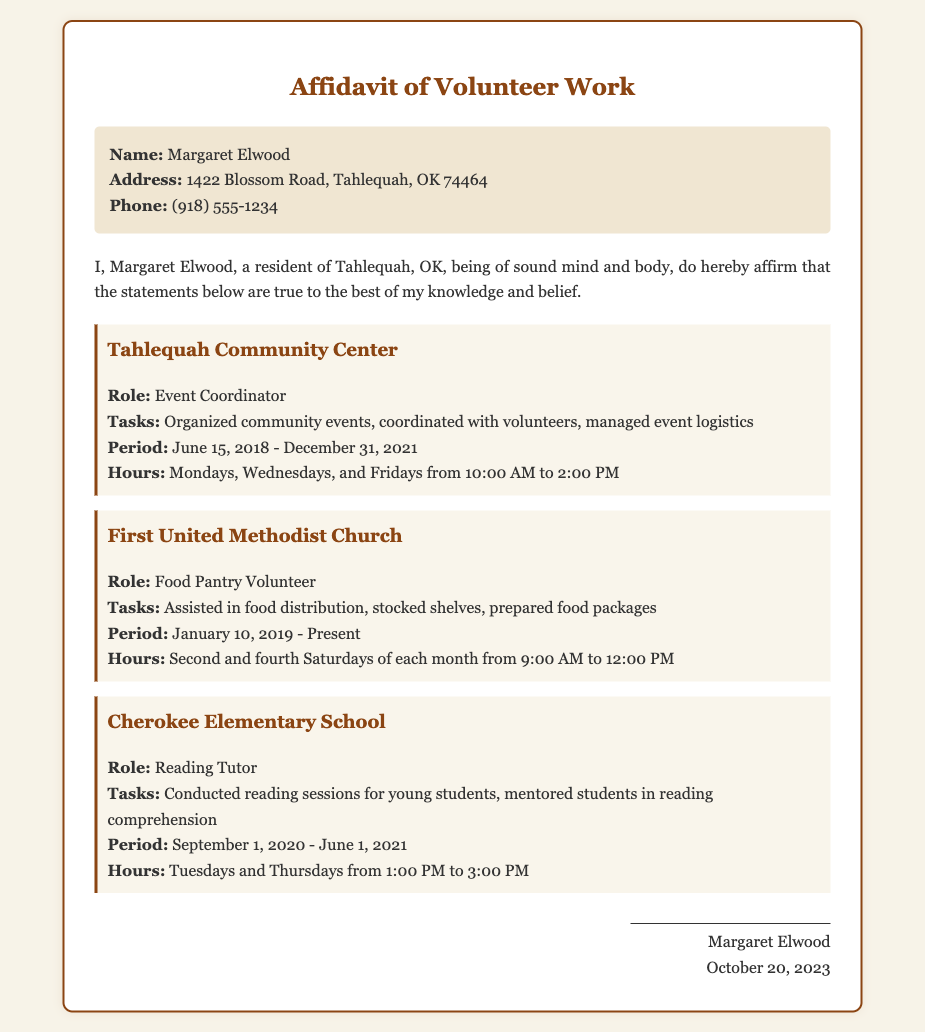What is the name of the individual affirming the statement? The individual's name in the affidavit is mentioned at the beginning, as Margaret Elwood.
Answer: Margaret Elwood What is the address listed for Margaret Elwood? The address is provided in the personal information section of the document.
Answer: 1422 Blossom Road, Tahlequah, OK 74464 What role did Margaret Elwood have at the Tahlequah Community Center? The document specifies her role in the section about her volunteer work at the community center.
Answer: Event Coordinator During what period did Margaret volunteer at First United Methodist Church? The timeline for volunteering at the church is stated clearly in the document.
Answer: January 10, 2019 - Present How often did Margaret volunteer at the Cherokee Elementary School? The document outlines her scheduled days for volunteering at the elementary school.
Answer: Tuesdays and Thursdays What tasks were performed by Margaret at the food pantry? The tasks she performed are listed under her role at the First United Methodist Church.
Answer: Assisted in food distribution, stocked shelves, prepared food packages What is the signature date on the affidavit? The date is provided at the bottom of the document along with Margaret's name.
Answer: October 20, 2023 How many days a week did Margaret volunteer at the Tahlequah Community Center? The schedule indicates specific days she volunteered, helping to determine the number of days.
Answer: Three days What event-related tasks did Margaret perform as an event coordinator? The tasks related to her role at the Tahlequah Community Center are listed.
Answer: Organized community events, coordinated with volunteers, managed event logistics 